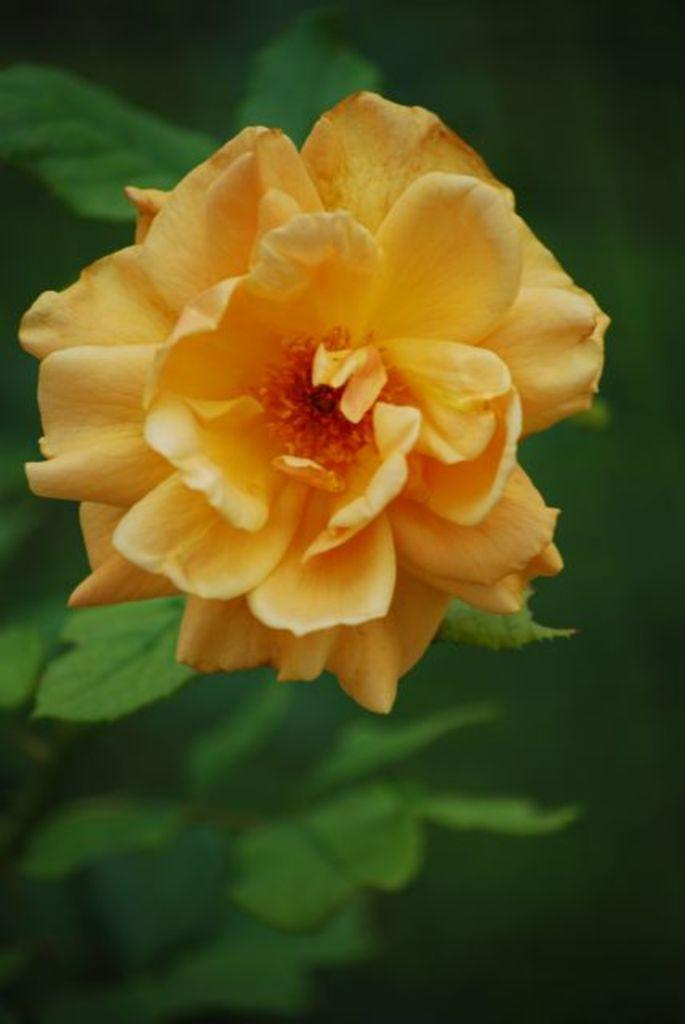What is the main subject of the image? There is a flower in the middle of the image. What can be seen in the background of the image? There are green leaves in the background of the image. How many cattle can be seen grazing on the coast in the image? There are no cattle or coast present in the image; it features a flower and green leaves. What type of calculator is being used by the flower in the image? There is no calculator present in the image, as it features a flower and green leaves. 